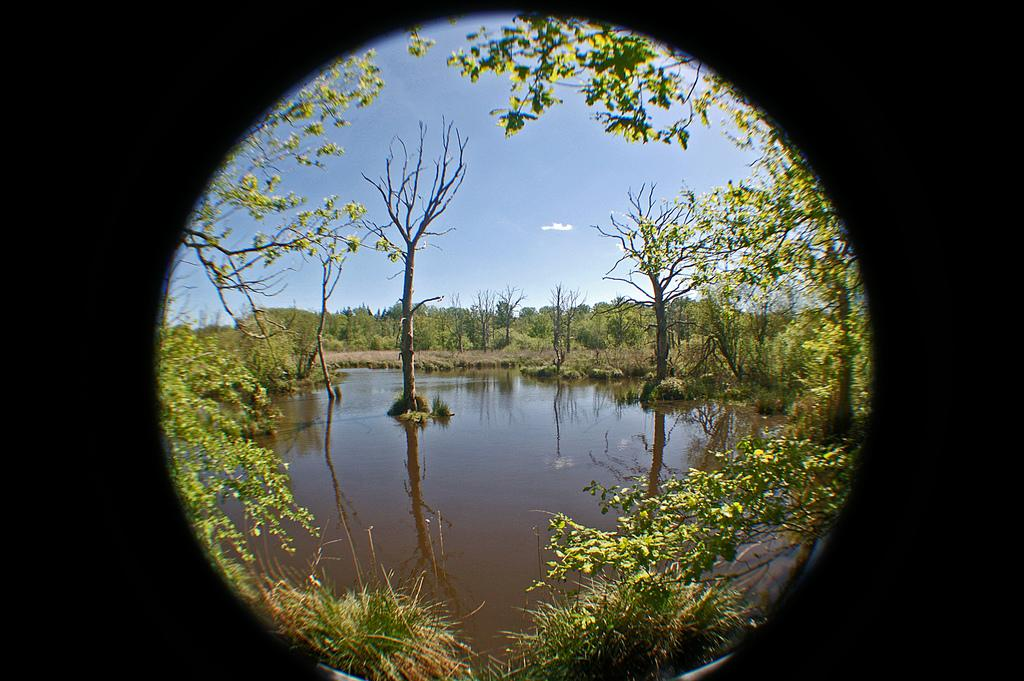What is the primary element visible in the image? The image contains the sky. What can be seen in the sky? Clouds are present in the image. What type of vegetation is visible in the image? There are trees and plants in the image. What is the nature of the water in the image? Water is present in the image. How is the image framed? The image has a black border around it. What type of rhythm can be heard in the image? There is no sound or rhythm present in the image, as it is a still picture. 